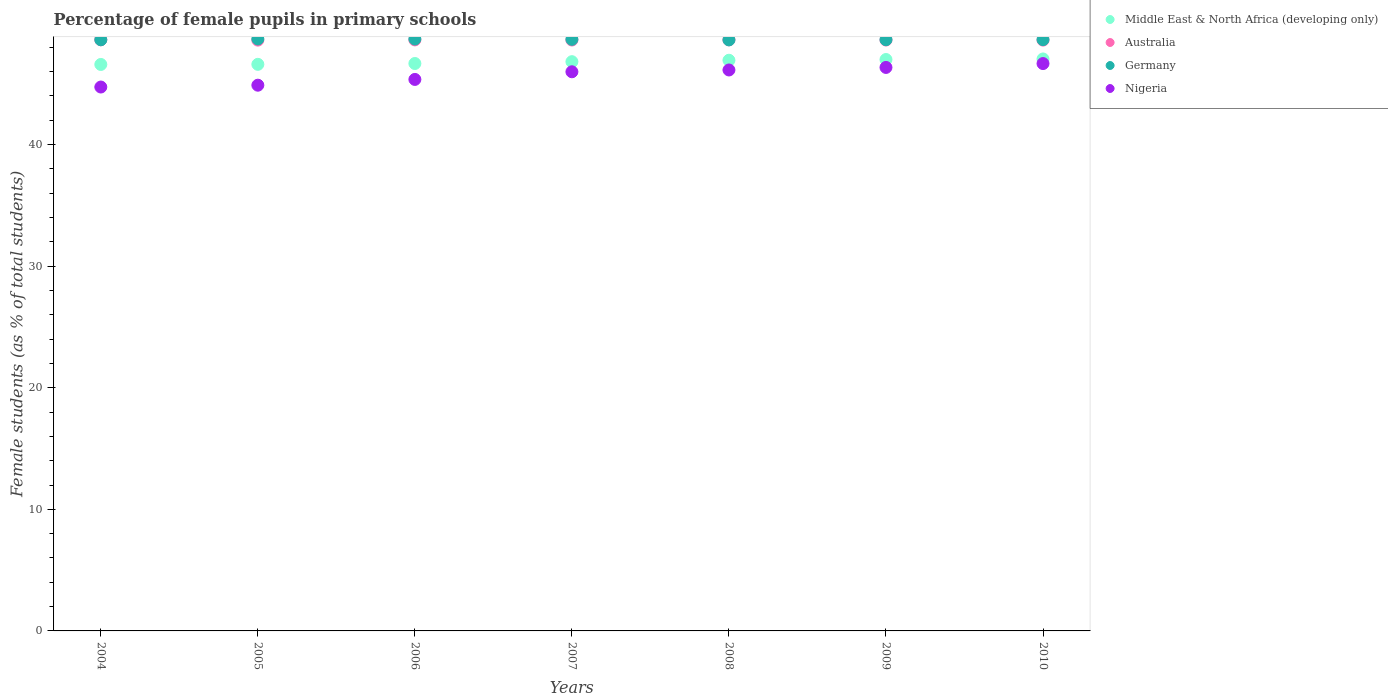What is the percentage of female pupils in primary schools in Australia in 2005?
Give a very brief answer. 48.59. Across all years, what is the maximum percentage of female pupils in primary schools in Nigeria?
Offer a very short reply. 46.66. Across all years, what is the minimum percentage of female pupils in primary schools in Germany?
Give a very brief answer. 48.61. In which year was the percentage of female pupils in primary schools in Australia maximum?
Ensure brevity in your answer.  2004. What is the total percentage of female pupils in primary schools in Nigeria in the graph?
Provide a succinct answer. 320.11. What is the difference between the percentage of female pupils in primary schools in Australia in 2004 and that in 2005?
Offer a very short reply. 0.02. What is the difference between the percentage of female pupils in primary schools in Germany in 2005 and the percentage of female pupils in primary schools in Australia in 2007?
Ensure brevity in your answer.  0.09. What is the average percentage of female pupils in primary schools in Nigeria per year?
Your answer should be compact. 45.73. In the year 2005, what is the difference between the percentage of female pupils in primary schools in Germany and percentage of female pupils in primary schools in Middle East & North Africa (developing only)?
Make the answer very short. 2.09. What is the ratio of the percentage of female pupils in primary schools in Germany in 2005 to that in 2008?
Provide a succinct answer. 1. Is the difference between the percentage of female pupils in primary schools in Germany in 2004 and 2008 greater than the difference between the percentage of female pupils in primary schools in Middle East & North Africa (developing only) in 2004 and 2008?
Offer a terse response. Yes. What is the difference between the highest and the second highest percentage of female pupils in primary schools in Nigeria?
Provide a succinct answer. 0.32. What is the difference between the highest and the lowest percentage of female pupils in primary schools in Nigeria?
Make the answer very short. 1.93. In how many years, is the percentage of female pupils in primary schools in Australia greater than the average percentage of female pupils in primary schools in Australia taken over all years?
Your answer should be very brief. 3. Is the sum of the percentage of female pupils in primary schools in Nigeria in 2005 and 2010 greater than the maximum percentage of female pupils in primary schools in Middle East & North Africa (developing only) across all years?
Ensure brevity in your answer.  Yes. Is it the case that in every year, the sum of the percentage of female pupils in primary schools in Australia and percentage of female pupils in primary schools in Nigeria  is greater than the sum of percentage of female pupils in primary schools in Germany and percentage of female pupils in primary schools in Middle East & North Africa (developing only)?
Give a very brief answer. No. Does the percentage of female pupils in primary schools in Germany monotonically increase over the years?
Offer a very short reply. No. Is the percentage of female pupils in primary schools in Germany strictly greater than the percentage of female pupils in primary schools in Nigeria over the years?
Your answer should be very brief. Yes. How many dotlines are there?
Make the answer very short. 4. How many years are there in the graph?
Your response must be concise. 7. What is the difference between two consecutive major ticks on the Y-axis?
Your answer should be very brief. 10. Does the graph contain any zero values?
Make the answer very short. No. How many legend labels are there?
Provide a succinct answer. 4. What is the title of the graph?
Your answer should be compact. Percentage of female pupils in primary schools. Does "French Polynesia" appear as one of the legend labels in the graph?
Offer a terse response. No. What is the label or title of the Y-axis?
Keep it short and to the point. Female students (as % of total students). What is the Female students (as % of total students) in Middle East & North Africa (developing only) in 2004?
Make the answer very short. 46.59. What is the Female students (as % of total students) in Australia in 2004?
Ensure brevity in your answer.  48.62. What is the Female students (as % of total students) in Germany in 2004?
Ensure brevity in your answer.  48.62. What is the Female students (as % of total students) in Nigeria in 2004?
Offer a very short reply. 44.73. What is the Female students (as % of total students) of Middle East & North Africa (developing only) in 2005?
Provide a succinct answer. 46.6. What is the Female students (as % of total students) of Australia in 2005?
Offer a terse response. 48.59. What is the Female students (as % of total students) of Germany in 2005?
Your answer should be very brief. 48.69. What is the Female students (as % of total students) in Nigeria in 2005?
Offer a terse response. 44.88. What is the Female students (as % of total students) of Middle East & North Africa (developing only) in 2006?
Your response must be concise. 46.67. What is the Female students (as % of total students) in Australia in 2006?
Your answer should be compact. 48.61. What is the Female students (as % of total students) in Germany in 2006?
Offer a terse response. 48.68. What is the Female students (as % of total students) of Nigeria in 2006?
Your answer should be very brief. 45.36. What is the Female students (as % of total students) in Middle East & North Africa (developing only) in 2007?
Make the answer very short. 46.82. What is the Female students (as % of total students) in Australia in 2007?
Your answer should be very brief. 48.6. What is the Female students (as % of total students) in Germany in 2007?
Give a very brief answer. 48.66. What is the Female students (as % of total students) of Nigeria in 2007?
Offer a terse response. 45.99. What is the Female students (as % of total students) in Middle East & North Africa (developing only) in 2008?
Your response must be concise. 46.94. What is the Female students (as % of total students) in Australia in 2008?
Offer a very short reply. 48.62. What is the Female students (as % of total students) in Germany in 2008?
Your answer should be compact. 48.61. What is the Female students (as % of total students) in Nigeria in 2008?
Keep it short and to the point. 46.14. What is the Female students (as % of total students) of Middle East & North Africa (developing only) in 2009?
Your answer should be compact. 47. What is the Female students (as % of total students) of Australia in 2009?
Provide a short and direct response. 48.6. What is the Female students (as % of total students) in Germany in 2009?
Ensure brevity in your answer.  48.63. What is the Female students (as % of total students) of Nigeria in 2009?
Your answer should be very brief. 46.35. What is the Female students (as % of total students) in Middle East & North Africa (developing only) in 2010?
Provide a succinct answer. 47.04. What is the Female students (as % of total students) of Australia in 2010?
Offer a very short reply. 48.59. What is the Female students (as % of total students) in Germany in 2010?
Offer a very short reply. 48.63. What is the Female students (as % of total students) in Nigeria in 2010?
Ensure brevity in your answer.  46.66. Across all years, what is the maximum Female students (as % of total students) of Middle East & North Africa (developing only)?
Offer a terse response. 47.04. Across all years, what is the maximum Female students (as % of total students) of Australia?
Give a very brief answer. 48.62. Across all years, what is the maximum Female students (as % of total students) in Germany?
Give a very brief answer. 48.69. Across all years, what is the maximum Female students (as % of total students) in Nigeria?
Keep it short and to the point. 46.66. Across all years, what is the minimum Female students (as % of total students) in Middle East & North Africa (developing only)?
Offer a terse response. 46.59. Across all years, what is the minimum Female students (as % of total students) in Australia?
Your answer should be compact. 48.59. Across all years, what is the minimum Female students (as % of total students) of Germany?
Provide a short and direct response. 48.61. Across all years, what is the minimum Female students (as % of total students) of Nigeria?
Give a very brief answer. 44.73. What is the total Female students (as % of total students) in Middle East & North Africa (developing only) in the graph?
Provide a short and direct response. 327.65. What is the total Female students (as % of total students) in Australia in the graph?
Give a very brief answer. 340.23. What is the total Female students (as % of total students) of Germany in the graph?
Offer a very short reply. 340.52. What is the total Female students (as % of total students) in Nigeria in the graph?
Provide a succinct answer. 320.11. What is the difference between the Female students (as % of total students) of Middle East & North Africa (developing only) in 2004 and that in 2005?
Provide a succinct answer. -0.01. What is the difference between the Female students (as % of total students) in Australia in 2004 and that in 2005?
Ensure brevity in your answer.  0.02. What is the difference between the Female students (as % of total students) in Germany in 2004 and that in 2005?
Make the answer very short. -0.06. What is the difference between the Female students (as % of total students) in Nigeria in 2004 and that in 2005?
Your answer should be compact. -0.15. What is the difference between the Female students (as % of total students) in Middle East & North Africa (developing only) in 2004 and that in 2006?
Provide a short and direct response. -0.08. What is the difference between the Female students (as % of total students) in Australia in 2004 and that in 2006?
Provide a short and direct response. 0.01. What is the difference between the Female students (as % of total students) in Germany in 2004 and that in 2006?
Make the answer very short. -0.06. What is the difference between the Female students (as % of total students) in Nigeria in 2004 and that in 2006?
Offer a terse response. -0.62. What is the difference between the Female students (as % of total students) of Middle East & North Africa (developing only) in 2004 and that in 2007?
Make the answer very short. -0.23. What is the difference between the Female students (as % of total students) of Australia in 2004 and that in 2007?
Give a very brief answer. 0.02. What is the difference between the Female students (as % of total students) of Germany in 2004 and that in 2007?
Your answer should be compact. -0.04. What is the difference between the Female students (as % of total students) of Nigeria in 2004 and that in 2007?
Offer a very short reply. -1.25. What is the difference between the Female students (as % of total students) of Middle East & North Africa (developing only) in 2004 and that in 2008?
Your answer should be very brief. -0.35. What is the difference between the Female students (as % of total students) of Australia in 2004 and that in 2008?
Your response must be concise. 0. What is the difference between the Female students (as % of total students) in Germany in 2004 and that in 2008?
Your response must be concise. 0.01. What is the difference between the Female students (as % of total students) in Nigeria in 2004 and that in 2008?
Your answer should be very brief. -1.4. What is the difference between the Female students (as % of total students) of Middle East & North Africa (developing only) in 2004 and that in 2009?
Keep it short and to the point. -0.41. What is the difference between the Female students (as % of total students) in Australia in 2004 and that in 2009?
Provide a succinct answer. 0.02. What is the difference between the Female students (as % of total students) of Germany in 2004 and that in 2009?
Your answer should be compact. -0.01. What is the difference between the Female students (as % of total students) of Nigeria in 2004 and that in 2009?
Your answer should be very brief. -1.61. What is the difference between the Female students (as % of total students) of Middle East & North Africa (developing only) in 2004 and that in 2010?
Keep it short and to the point. -0.45. What is the difference between the Female students (as % of total students) in Australia in 2004 and that in 2010?
Your response must be concise. 0.02. What is the difference between the Female students (as % of total students) in Germany in 2004 and that in 2010?
Provide a short and direct response. -0.01. What is the difference between the Female students (as % of total students) of Nigeria in 2004 and that in 2010?
Offer a very short reply. -1.93. What is the difference between the Female students (as % of total students) of Middle East & North Africa (developing only) in 2005 and that in 2006?
Your answer should be compact. -0.07. What is the difference between the Female students (as % of total students) of Australia in 2005 and that in 2006?
Make the answer very short. -0.02. What is the difference between the Female students (as % of total students) of Germany in 2005 and that in 2006?
Your response must be concise. 0.01. What is the difference between the Female students (as % of total students) of Nigeria in 2005 and that in 2006?
Your answer should be very brief. -0.47. What is the difference between the Female students (as % of total students) in Middle East & North Africa (developing only) in 2005 and that in 2007?
Your answer should be very brief. -0.22. What is the difference between the Female students (as % of total students) in Australia in 2005 and that in 2007?
Provide a succinct answer. -0.01. What is the difference between the Female students (as % of total students) of Germany in 2005 and that in 2007?
Your answer should be compact. 0.03. What is the difference between the Female students (as % of total students) in Nigeria in 2005 and that in 2007?
Your answer should be very brief. -1.1. What is the difference between the Female students (as % of total students) in Middle East & North Africa (developing only) in 2005 and that in 2008?
Your response must be concise. -0.34. What is the difference between the Female students (as % of total students) of Australia in 2005 and that in 2008?
Offer a very short reply. -0.02. What is the difference between the Female students (as % of total students) in Germany in 2005 and that in 2008?
Provide a short and direct response. 0.08. What is the difference between the Female students (as % of total students) in Nigeria in 2005 and that in 2008?
Keep it short and to the point. -1.25. What is the difference between the Female students (as % of total students) of Middle East & North Africa (developing only) in 2005 and that in 2009?
Keep it short and to the point. -0.4. What is the difference between the Female students (as % of total students) in Australia in 2005 and that in 2009?
Give a very brief answer. -0.01. What is the difference between the Female students (as % of total students) in Germany in 2005 and that in 2009?
Ensure brevity in your answer.  0.06. What is the difference between the Female students (as % of total students) in Nigeria in 2005 and that in 2009?
Keep it short and to the point. -1.46. What is the difference between the Female students (as % of total students) in Middle East & North Africa (developing only) in 2005 and that in 2010?
Your answer should be very brief. -0.44. What is the difference between the Female students (as % of total students) in Australia in 2005 and that in 2010?
Offer a very short reply. -0. What is the difference between the Female students (as % of total students) in Germany in 2005 and that in 2010?
Offer a very short reply. 0.05. What is the difference between the Female students (as % of total students) of Nigeria in 2005 and that in 2010?
Offer a very short reply. -1.78. What is the difference between the Female students (as % of total students) of Middle East & North Africa (developing only) in 2006 and that in 2007?
Keep it short and to the point. -0.15. What is the difference between the Female students (as % of total students) in Australia in 2006 and that in 2007?
Your response must be concise. 0.01. What is the difference between the Female students (as % of total students) of Germany in 2006 and that in 2007?
Ensure brevity in your answer.  0.02. What is the difference between the Female students (as % of total students) of Nigeria in 2006 and that in 2007?
Your answer should be very brief. -0.63. What is the difference between the Female students (as % of total students) of Middle East & North Africa (developing only) in 2006 and that in 2008?
Your answer should be compact. -0.27. What is the difference between the Female students (as % of total students) in Australia in 2006 and that in 2008?
Provide a succinct answer. -0.01. What is the difference between the Female students (as % of total students) in Germany in 2006 and that in 2008?
Your answer should be very brief. 0.07. What is the difference between the Female students (as % of total students) of Nigeria in 2006 and that in 2008?
Provide a succinct answer. -0.78. What is the difference between the Female students (as % of total students) in Middle East & North Africa (developing only) in 2006 and that in 2009?
Give a very brief answer. -0.33. What is the difference between the Female students (as % of total students) in Germany in 2006 and that in 2009?
Make the answer very short. 0.05. What is the difference between the Female students (as % of total students) in Nigeria in 2006 and that in 2009?
Provide a succinct answer. -0.99. What is the difference between the Female students (as % of total students) in Middle East & North Africa (developing only) in 2006 and that in 2010?
Your response must be concise. -0.37. What is the difference between the Female students (as % of total students) in Australia in 2006 and that in 2010?
Your response must be concise. 0.02. What is the difference between the Female students (as % of total students) in Germany in 2006 and that in 2010?
Offer a terse response. 0.05. What is the difference between the Female students (as % of total students) in Nigeria in 2006 and that in 2010?
Your answer should be very brief. -1.31. What is the difference between the Female students (as % of total students) of Middle East & North Africa (developing only) in 2007 and that in 2008?
Ensure brevity in your answer.  -0.12. What is the difference between the Female students (as % of total students) in Australia in 2007 and that in 2008?
Your response must be concise. -0.02. What is the difference between the Female students (as % of total students) in Germany in 2007 and that in 2008?
Provide a short and direct response. 0.05. What is the difference between the Female students (as % of total students) in Nigeria in 2007 and that in 2008?
Your answer should be very brief. -0.15. What is the difference between the Female students (as % of total students) in Middle East & North Africa (developing only) in 2007 and that in 2009?
Ensure brevity in your answer.  -0.18. What is the difference between the Female students (as % of total students) of Australia in 2007 and that in 2009?
Offer a very short reply. -0. What is the difference between the Female students (as % of total students) of Germany in 2007 and that in 2009?
Your answer should be compact. 0.03. What is the difference between the Female students (as % of total students) in Nigeria in 2007 and that in 2009?
Your answer should be compact. -0.36. What is the difference between the Female students (as % of total students) of Middle East & North Africa (developing only) in 2007 and that in 2010?
Offer a very short reply. -0.22. What is the difference between the Female students (as % of total students) of Australia in 2007 and that in 2010?
Keep it short and to the point. 0.01. What is the difference between the Female students (as % of total students) of Germany in 2007 and that in 2010?
Offer a very short reply. 0.02. What is the difference between the Female students (as % of total students) of Nigeria in 2007 and that in 2010?
Your answer should be compact. -0.68. What is the difference between the Female students (as % of total students) of Middle East & North Africa (developing only) in 2008 and that in 2009?
Offer a terse response. -0.06. What is the difference between the Female students (as % of total students) in Australia in 2008 and that in 2009?
Offer a very short reply. 0.02. What is the difference between the Female students (as % of total students) in Germany in 2008 and that in 2009?
Your answer should be compact. -0.02. What is the difference between the Female students (as % of total students) of Nigeria in 2008 and that in 2009?
Your response must be concise. -0.21. What is the difference between the Female students (as % of total students) in Middle East & North Africa (developing only) in 2008 and that in 2010?
Keep it short and to the point. -0.11. What is the difference between the Female students (as % of total students) of Australia in 2008 and that in 2010?
Make the answer very short. 0.02. What is the difference between the Female students (as % of total students) of Germany in 2008 and that in 2010?
Your response must be concise. -0.02. What is the difference between the Female students (as % of total students) in Nigeria in 2008 and that in 2010?
Offer a very short reply. -0.53. What is the difference between the Female students (as % of total students) of Middle East & North Africa (developing only) in 2009 and that in 2010?
Make the answer very short. -0.05. What is the difference between the Female students (as % of total students) of Australia in 2009 and that in 2010?
Keep it short and to the point. 0.01. What is the difference between the Female students (as % of total students) in Germany in 2009 and that in 2010?
Provide a short and direct response. -0.01. What is the difference between the Female students (as % of total students) in Nigeria in 2009 and that in 2010?
Offer a very short reply. -0.32. What is the difference between the Female students (as % of total students) of Middle East & North Africa (developing only) in 2004 and the Female students (as % of total students) of Australia in 2005?
Your answer should be very brief. -2. What is the difference between the Female students (as % of total students) in Middle East & North Africa (developing only) in 2004 and the Female students (as % of total students) in Germany in 2005?
Provide a short and direct response. -2.1. What is the difference between the Female students (as % of total students) of Middle East & North Africa (developing only) in 2004 and the Female students (as % of total students) of Nigeria in 2005?
Your answer should be very brief. 1.71. What is the difference between the Female students (as % of total students) in Australia in 2004 and the Female students (as % of total students) in Germany in 2005?
Your answer should be very brief. -0.07. What is the difference between the Female students (as % of total students) in Australia in 2004 and the Female students (as % of total students) in Nigeria in 2005?
Make the answer very short. 3.73. What is the difference between the Female students (as % of total students) in Germany in 2004 and the Female students (as % of total students) in Nigeria in 2005?
Offer a very short reply. 3.74. What is the difference between the Female students (as % of total students) in Middle East & North Africa (developing only) in 2004 and the Female students (as % of total students) in Australia in 2006?
Offer a very short reply. -2.02. What is the difference between the Female students (as % of total students) of Middle East & North Africa (developing only) in 2004 and the Female students (as % of total students) of Germany in 2006?
Offer a very short reply. -2.09. What is the difference between the Female students (as % of total students) in Middle East & North Africa (developing only) in 2004 and the Female students (as % of total students) in Nigeria in 2006?
Your response must be concise. 1.23. What is the difference between the Female students (as % of total students) of Australia in 2004 and the Female students (as % of total students) of Germany in 2006?
Ensure brevity in your answer.  -0.06. What is the difference between the Female students (as % of total students) of Australia in 2004 and the Female students (as % of total students) of Nigeria in 2006?
Provide a short and direct response. 3.26. What is the difference between the Female students (as % of total students) in Germany in 2004 and the Female students (as % of total students) in Nigeria in 2006?
Your answer should be very brief. 3.26. What is the difference between the Female students (as % of total students) of Middle East & North Africa (developing only) in 2004 and the Female students (as % of total students) of Australia in 2007?
Your answer should be compact. -2.01. What is the difference between the Female students (as % of total students) of Middle East & North Africa (developing only) in 2004 and the Female students (as % of total students) of Germany in 2007?
Make the answer very short. -2.07. What is the difference between the Female students (as % of total students) of Middle East & North Africa (developing only) in 2004 and the Female students (as % of total students) of Nigeria in 2007?
Provide a succinct answer. 0.6. What is the difference between the Female students (as % of total students) of Australia in 2004 and the Female students (as % of total students) of Germany in 2007?
Offer a terse response. -0.04. What is the difference between the Female students (as % of total students) of Australia in 2004 and the Female students (as % of total students) of Nigeria in 2007?
Your answer should be compact. 2.63. What is the difference between the Female students (as % of total students) of Germany in 2004 and the Female students (as % of total students) of Nigeria in 2007?
Keep it short and to the point. 2.63. What is the difference between the Female students (as % of total students) of Middle East & North Africa (developing only) in 2004 and the Female students (as % of total students) of Australia in 2008?
Provide a succinct answer. -2.03. What is the difference between the Female students (as % of total students) in Middle East & North Africa (developing only) in 2004 and the Female students (as % of total students) in Germany in 2008?
Your answer should be very brief. -2.02. What is the difference between the Female students (as % of total students) of Middle East & North Africa (developing only) in 2004 and the Female students (as % of total students) of Nigeria in 2008?
Ensure brevity in your answer.  0.45. What is the difference between the Female students (as % of total students) of Australia in 2004 and the Female students (as % of total students) of Germany in 2008?
Your answer should be compact. 0.01. What is the difference between the Female students (as % of total students) in Australia in 2004 and the Female students (as % of total students) in Nigeria in 2008?
Your answer should be compact. 2.48. What is the difference between the Female students (as % of total students) in Germany in 2004 and the Female students (as % of total students) in Nigeria in 2008?
Offer a terse response. 2.49. What is the difference between the Female students (as % of total students) in Middle East & North Africa (developing only) in 2004 and the Female students (as % of total students) in Australia in 2009?
Offer a very short reply. -2.01. What is the difference between the Female students (as % of total students) of Middle East & North Africa (developing only) in 2004 and the Female students (as % of total students) of Germany in 2009?
Your response must be concise. -2.04. What is the difference between the Female students (as % of total students) in Middle East & North Africa (developing only) in 2004 and the Female students (as % of total students) in Nigeria in 2009?
Provide a succinct answer. 0.24. What is the difference between the Female students (as % of total students) of Australia in 2004 and the Female students (as % of total students) of Germany in 2009?
Provide a short and direct response. -0.01. What is the difference between the Female students (as % of total students) of Australia in 2004 and the Female students (as % of total students) of Nigeria in 2009?
Make the answer very short. 2.27. What is the difference between the Female students (as % of total students) in Germany in 2004 and the Female students (as % of total students) in Nigeria in 2009?
Your response must be concise. 2.28. What is the difference between the Female students (as % of total students) in Middle East & North Africa (developing only) in 2004 and the Female students (as % of total students) in Australia in 2010?
Offer a terse response. -2. What is the difference between the Female students (as % of total students) in Middle East & North Africa (developing only) in 2004 and the Female students (as % of total students) in Germany in 2010?
Ensure brevity in your answer.  -2.04. What is the difference between the Female students (as % of total students) of Middle East & North Africa (developing only) in 2004 and the Female students (as % of total students) of Nigeria in 2010?
Give a very brief answer. -0.07. What is the difference between the Female students (as % of total students) in Australia in 2004 and the Female students (as % of total students) in Germany in 2010?
Offer a very short reply. -0.02. What is the difference between the Female students (as % of total students) in Australia in 2004 and the Female students (as % of total students) in Nigeria in 2010?
Keep it short and to the point. 1.95. What is the difference between the Female students (as % of total students) of Germany in 2004 and the Female students (as % of total students) of Nigeria in 2010?
Offer a very short reply. 1.96. What is the difference between the Female students (as % of total students) of Middle East & North Africa (developing only) in 2005 and the Female students (as % of total students) of Australia in 2006?
Offer a terse response. -2.01. What is the difference between the Female students (as % of total students) of Middle East & North Africa (developing only) in 2005 and the Female students (as % of total students) of Germany in 2006?
Offer a very short reply. -2.08. What is the difference between the Female students (as % of total students) of Middle East & North Africa (developing only) in 2005 and the Female students (as % of total students) of Nigeria in 2006?
Make the answer very short. 1.24. What is the difference between the Female students (as % of total students) in Australia in 2005 and the Female students (as % of total students) in Germany in 2006?
Your answer should be very brief. -0.09. What is the difference between the Female students (as % of total students) of Australia in 2005 and the Female students (as % of total students) of Nigeria in 2006?
Your response must be concise. 3.23. What is the difference between the Female students (as % of total students) of Germany in 2005 and the Female students (as % of total students) of Nigeria in 2006?
Your response must be concise. 3.33. What is the difference between the Female students (as % of total students) of Middle East & North Africa (developing only) in 2005 and the Female students (as % of total students) of Australia in 2007?
Your answer should be compact. -2. What is the difference between the Female students (as % of total students) of Middle East & North Africa (developing only) in 2005 and the Female students (as % of total students) of Germany in 2007?
Provide a succinct answer. -2.06. What is the difference between the Female students (as % of total students) of Middle East & North Africa (developing only) in 2005 and the Female students (as % of total students) of Nigeria in 2007?
Provide a short and direct response. 0.61. What is the difference between the Female students (as % of total students) in Australia in 2005 and the Female students (as % of total students) in Germany in 2007?
Keep it short and to the point. -0.06. What is the difference between the Female students (as % of total students) of Australia in 2005 and the Female students (as % of total students) of Nigeria in 2007?
Your response must be concise. 2.6. What is the difference between the Female students (as % of total students) in Germany in 2005 and the Female students (as % of total students) in Nigeria in 2007?
Provide a succinct answer. 2.7. What is the difference between the Female students (as % of total students) of Middle East & North Africa (developing only) in 2005 and the Female students (as % of total students) of Australia in 2008?
Offer a very short reply. -2.02. What is the difference between the Female students (as % of total students) in Middle East & North Africa (developing only) in 2005 and the Female students (as % of total students) in Germany in 2008?
Offer a very short reply. -2.01. What is the difference between the Female students (as % of total students) of Middle East & North Africa (developing only) in 2005 and the Female students (as % of total students) of Nigeria in 2008?
Your response must be concise. 0.46. What is the difference between the Female students (as % of total students) of Australia in 2005 and the Female students (as % of total students) of Germany in 2008?
Your response must be concise. -0.02. What is the difference between the Female students (as % of total students) in Australia in 2005 and the Female students (as % of total students) in Nigeria in 2008?
Keep it short and to the point. 2.46. What is the difference between the Female students (as % of total students) in Germany in 2005 and the Female students (as % of total students) in Nigeria in 2008?
Offer a very short reply. 2.55. What is the difference between the Female students (as % of total students) in Middle East & North Africa (developing only) in 2005 and the Female students (as % of total students) in Australia in 2009?
Your response must be concise. -2. What is the difference between the Female students (as % of total students) in Middle East & North Africa (developing only) in 2005 and the Female students (as % of total students) in Germany in 2009?
Your answer should be compact. -2.03. What is the difference between the Female students (as % of total students) of Middle East & North Africa (developing only) in 2005 and the Female students (as % of total students) of Nigeria in 2009?
Keep it short and to the point. 0.25. What is the difference between the Female students (as % of total students) of Australia in 2005 and the Female students (as % of total students) of Germany in 2009?
Offer a very short reply. -0.03. What is the difference between the Female students (as % of total students) in Australia in 2005 and the Female students (as % of total students) in Nigeria in 2009?
Your answer should be compact. 2.25. What is the difference between the Female students (as % of total students) in Germany in 2005 and the Female students (as % of total students) in Nigeria in 2009?
Your answer should be very brief. 2.34. What is the difference between the Female students (as % of total students) in Middle East & North Africa (developing only) in 2005 and the Female students (as % of total students) in Australia in 2010?
Your answer should be very brief. -1.99. What is the difference between the Female students (as % of total students) in Middle East & North Africa (developing only) in 2005 and the Female students (as % of total students) in Germany in 2010?
Your response must be concise. -2.03. What is the difference between the Female students (as % of total students) of Middle East & North Africa (developing only) in 2005 and the Female students (as % of total students) of Nigeria in 2010?
Ensure brevity in your answer.  -0.06. What is the difference between the Female students (as % of total students) of Australia in 2005 and the Female students (as % of total students) of Germany in 2010?
Your response must be concise. -0.04. What is the difference between the Female students (as % of total students) in Australia in 2005 and the Female students (as % of total students) in Nigeria in 2010?
Your answer should be compact. 1.93. What is the difference between the Female students (as % of total students) in Germany in 2005 and the Female students (as % of total students) in Nigeria in 2010?
Provide a succinct answer. 2.02. What is the difference between the Female students (as % of total students) of Middle East & North Africa (developing only) in 2006 and the Female students (as % of total students) of Australia in 2007?
Offer a very short reply. -1.93. What is the difference between the Female students (as % of total students) in Middle East & North Africa (developing only) in 2006 and the Female students (as % of total students) in Germany in 2007?
Ensure brevity in your answer.  -1.99. What is the difference between the Female students (as % of total students) in Middle East & North Africa (developing only) in 2006 and the Female students (as % of total students) in Nigeria in 2007?
Provide a succinct answer. 0.68. What is the difference between the Female students (as % of total students) of Australia in 2006 and the Female students (as % of total students) of Germany in 2007?
Ensure brevity in your answer.  -0.05. What is the difference between the Female students (as % of total students) in Australia in 2006 and the Female students (as % of total students) in Nigeria in 2007?
Keep it short and to the point. 2.62. What is the difference between the Female students (as % of total students) in Germany in 2006 and the Female students (as % of total students) in Nigeria in 2007?
Provide a succinct answer. 2.69. What is the difference between the Female students (as % of total students) of Middle East & North Africa (developing only) in 2006 and the Female students (as % of total students) of Australia in 2008?
Your answer should be very brief. -1.95. What is the difference between the Female students (as % of total students) in Middle East & North Africa (developing only) in 2006 and the Female students (as % of total students) in Germany in 2008?
Make the answer very short. -1.94. What is the difference between the Female students (as % of total students) in Middle East & North Africa (developing only) in 2006 and the Female students (as % of total students) in Nigeria in 2008?
Ensure brevity in your answer.  0.53. What is the difference between the Female students (as % of total students) of Australia in 2006 and the Female students (as % of total students) of Germany in 2008?
Give a very brief answer. -0. What is the difference between the Female students (as % of total students) of Australia in 2006 and the Female students (as % of total students) of Nigeria in 2008?
Your response must be concise. 2.47. What is the difference between the Female students (as % of total students) of Germany in 2006 and the Female students (as % of total students) of Nigeria in 2008?
Offer a terse response. 2.54. What is the difference between the Female students (as % of total students) of Middle East & North Africa (developing only) in 2006 and the Female students (as % of total students) of Australia in 2009?
Make the answer very short. -1.93. What is the difference between the Female students (as % of total students) of Middle East & North Africa (developing only) in 2006 and the Female students (as % of total students) of Germany in 2009?
Provide a short and direct response. -1.96. What is the difference between the Female students (as % of total students) in Middle East & North Africa (developing only) in 2006 and the Female students (as % of total students) in Nigeria in 2009?
Ensure brevity in your answer.  0.32. What is the difference between the Female students (as % of total students) of Australia in 2006 and the Female students (as % of total students) of Germany in 2009?
Offer a very short reply. -0.02. What is the difference between the Female students (as % of total students) in Australia in 2006 and the Female students (as % of total students) in Nigeria in 2009?
Your answer should be very brief. 2.26. What is the difference between the Female students (as % of total students) in Germany in 2006 and the Female students (as % of total students) in Nigeria in 2009?
Keep it short and to the point. 2.33. What is the difference between the Female students (as % of total students) of Middle East & North Africa (developing only) in 2006 and the Female students (as % of total students) of Australia in 2010?
Your response must be concise. -1.92. What is the difference between the Female students (as % of total students) of Middle East & North Africa (developing only) in 2006 and the Female students (as % of total students) of Germany in 2010?
Your response must be concise. -1.97. What is the difference between the Female students (as % of total students) in Middle East & North Africa (developing only) in 2006 and the Female students (as % of total students) in Nigeria in 2010?
Your response must be concise. 0. What is the difference between the Female students (as % of total students) of Australia in 2006 and the Female students (as % of total students) of Germany in 2010?
Your answer should be compact. -0.02. What is the difference between the Female students (as % of total students) of Australia in 2006 and the Female students (as % of total students) of Nigeria in 2010?
Offer a terse response. 1.95. What is the difference between the Female students (as % of total students) in Germany in 2006 and the Female students (as % of total students) in Nigeria in 2010?
Your answer should be compact. 2.02. What is the difference between the Female students (as % of total students) in Middle East & North Africa (developing only) in 2007 and the Female students (as % of total students) in Australia in 2008?
Your answer should be compact. -1.8. What is the difference between the Female students (as % of total students) in Middle East & North Africa (developing only) in 2007 and the Female students (as % of total students) in Germany in 2008?
Offer a terse response. -1.79. What is the difference between the Female students (as % of total students) in Middle East & North Africa (developing only) in 2007 and the Female students (as % of total students) in Nigeria in 2008?
Offer a terse response. 0.68. What is the difference between the Female students (as % of total students) of Australia in 2007 and the Female students (as % of total students) of Germany in 2008?
Offer a terse response. -0.01. What is the difference between the Female students (as % of total students) of Australia in 2007 and the Female students (as % of total students) of Nigeria in 2008?
Make the answer very short. 2.46. What is the difference between the Female students (as % of total students) of Germany in 2007 and the Female students (as % of total students) of Nigeria in 2008?
Keep it short and to the point. 2.52. What is the difference between the Female students (as % of total students) in Middle East & North Africa (developing only) in 2007 and the Female students (as % of total students) in Australia in 2009?
Give a very brief answer. -1.78. What is the difference between the Female students (as % of total students) of Middle East & North Africa (developing only) in 2007 and the Female students (as % of total students) of Germany in 2009?
Give a very brief answer. -1.81. What is the difference between the Female students (as % of total students) of Middle East & North Africa (developing only) in 2007 and the Female students (as % of total students) of Nigeria in 2009?
Your answer should be compact. 0.47. What is the difference between the Female students (as % of total students) of Australia in 2007 and the Female students (as % of total students) of Germany in 2009?
Provide a succinct answer. -0.03. What is the difference between the Female students (as % of total students) of Australia in 2007 and the Female students (as % of total students) of Nigeria in 2009?
Your response must be concise. 2.25. What is the difference between the Female students (as % of total students) of Germany in 2007 and the Female students (as % of total students) of Nigeria in 2009?
Ensure brevity in your answer.  2.31. What is the difference between the Female students (as % of total students) in Middle East & North Africa (developing only) in 2007 and the Female students (as % of total students) in Australia in 2010?
Your answer should be compact. -1.77. What is the difference between the Female students (as % of total students) in Middle East & North Africa (developing only) in 2007 and the Female students (as % of total students) in Germany in 2010?
Make the answer very short. -1.82. What is the difference between the Female students (as % of total students) of Middle East & North Africa (developing only) in 2007 and the Female students (as % of total students) of Nigeria in 2010?
Your response must be concise. 0.15. What is the difference between the Female students (as % of total students) in Australia in 2007 and the Female students (as % of total students) in Germany in 2010?
Give a very brief answer. -0.03. What is the difference between the Female students (as % of total students) in Australia in 2007 and the Female students (as % of total students) in Nigeria in 2010?
Your response must be concise. 1.94. What is the difference between the Female students (as % of total students) in Germany in 2007 and the Female students (as % of total students) in Nigeria in 2010?
Provide a short and direct response. 1.99. What is the difference between the Female students (as % of total students) of Middle East & North Africa (developing only) in 2008 and the Female students (as % of total students) of Australia in 2009?
Offer a very short reply. -1.66. What is the difference between the Female students (as % of total students) in Middle East & North Africa (developing only) in 2008 and the Female students (as % of total students) in Germany in 2009?
Your answer should be very brief. -1.69. What is the difference between the Female students (as % of total students) in Middle East & North Africa (developing only) in 2008 and the Female students (as % of total students) in Nigeria in 2009?
Provide a short and direct response. 0.59. What is the difference between the Female students (as % of total students) of Australia in 2008 and the Female students (as % of total students) of Germany in 2009?
Make the answer very short. -0.01. What is the difference between the Female students (as % of total students) in Australia in 2008 and the Female students (as % of total students) in Nigeria in 2009?
Your answer should be very brief. 2.27. What is the difference between the Female students (as % of total students) of Germany in 2008 and the Female students (as % of total students) of Nigeria in 2009?
Ensure brevity in your answer.  2.26. What is the difference between the Female students (as % of total students) in Middle East & North Africa (developing only) in 2008 and the Female students (as % of total students) in Australia in 2010?
Make the answer very short. -1.66. What is the difference between the Female students (as % of total students) in Middle East & North Africa (developing only) in 2008 and the Female students (as % of total students) in Germany in 2010?
Your answer should be very brief. -1.7. What is the difference between the Female students (as % of total students) of Middle East & North Africa (developing only) in 2008 and the Female students (as % of total students) of Nigeria in 2010?
Ensure brevity in your answer.  0.27. What is the difference between the Female students (as % of total students) of Australia in 2008 and the Female students (as % of total students) of Germany in 2010?
Your answer should be very brief. -0.02. What is the difference between the Female students (as % of total students) of Australia in 2008 and the Female students (as % of total students) of Nigeria in 2010?
Your answer should be compact. 1.95. What is the difference between the Female students (as % of total students) of Germany in 2008 and the Female students (as % of total students) of Nigeria in 2010?
Offer a terse response. 1.95. What is the difference between the Female students (as % of total students) of Middle East & North Africa (developing only) in 2009 and the Female students (as % of total students) of Australia in 2010?
Your answer should be compact. -1.6. What is the difference between the Female students (as % of total students) of Middle East & North Africa (developing only) in 2009 and the Female students (as % of total students) of Germany in 2010?
Provide a short and direct response. -1.64. What is the difference between the Female students (as % of total students) of Middle East & North Africa (developing only) in 2009 and the Female students (as % of total students) of Nigeria in 2010?
Give a very brief answer. 0.33. What is the difference between the Female students (as % of total students) in Australia in 2009 and the Female students (as % of total students) in Germany in 2010?
Your answer should be compact. -0.03. What is the difference between the Female students (as % of total students) of Australia in 2009 and the Female students (as % of total students) of Nigeria in 2010?
Give a very brief answer. 1.94. What is the difference between the Female students (as % of total students) of Germany in 2009 and the Female students (as % of total students) of Nigeria in 2010?
Ensure brevity in your answer.  1.96. What is the average Female students (as % of total students) in Middle East & North Africa (developing only) per year?
Your response must be concise. 46.81. What is the average Female students (as % of total students) of Australia per year?
Offer a terse response. 48.6. What is the average Female students (as % of total students) of Germany per year?
Keep it short and to the point. 48.65. What is the average Female students (as % of total students) in Nigeria per year?
Offer a terse response. 45.73. In the year 2004, what is the difference between the Female students (as % of total students) in Middle East & North Africa (developing only) and Female students (as % of total students) in Australia?
Provide a short and direct response. -2.03. In the year 2004, what is the difference between the Female students (as % of total students) in Middle East & North Africa (developing only) and Female students (as % of total students) in Germany?
Keep it short and to the point. -2.03. In the year 2004, what is the difference between the Female students (as % of total students) in Middle East & North Africa (developing only) and Female students (as % of total students) in Nigeria?
Ensure brevity in your answer.  1.86. In the year 2004, what is the difference between the Female students (as % of total students) in Australia and Female students (as % of total students) in Germany?
Make the answer very short. -0. In the year 2004, what is the difference between the Female students (as % of total students) of Australia and Female students (as % of total students) of Nigeria?
Make the answer very short. 3.88. In the year 2004, what is the difference between the Female students (as % of total students) of Germany and Female students (as % of total students) of Nigeria?
Offer a very short reply. 3.89. In the year 2005, what is the difference between the Female students (as % of total students) of Middle East & North Africa (developing only) and Female students (as % of total students) of Australia?
Offer a very short reply. -1.99. In the year 2005, what is the difference between the Female students (as % of total students) of Middle East & North Africa (developing only) and Female students (as % of total students) of Germany?
Your answer should be very brief. -2.09. In the year 2005, what is the difference between the Female students (as % of total students) of Middle East & North Africa (developing only) and Female students (as % of total students) of Nigeria?
Your answer should be compact. 1.72. In the year 2005, what is the difference between the Female students (as % of total students) in Australia and Female students (as % of total students) in Germany?
Provide a succinct answer. -0.09. In the year 2005, what is the difference between the Female students (as % of total students) in Australia and Female students (as % of total students) in Nigeria?
Your answer should be compact. 3.71. In the year 2005, what is the difference between the Female students (as % of total students) of Germany and Female students (as % of total students) of Nigeria?
Offer a very short reply. 3.8. In the year 2006, what is the difference between the Female students (as % of total students) in Middle East & North Africa (developing only) and Female students (as % of total students) in Australia?
Your answer should be compact. -1.94. In the year 2006, what is the difference between the Female students (as % of total students) of Middle East & North Africa (developing only) and Female students (as % of total students) of Germany?
Give a very brief answer. -2.01. In the year 2006, what is the difference between the Female students (as % of total students) of Middle East & North Africa (developing only) and Female students (as % of total students) of Nigeria?
Ensure brevity in your answer.  1.31. In the year 2006, what is the difference between the Female students (as % of total students) in Australia and Female students (as % of total students) in Germany?
Ensure brevity in your answer.  -0.07. In the year 2006, what is the difference between the Female students (as % of total students) of Australia and Female students (as % of total students) of Nigeria?
Give a very brief answer. 3.25. In the year 2006, what is the difference between the Female students (as % of total students) in Germany and Female students (as % of total students) in Nigeria?
Ensure brevity in your answer.  3.32. In the year 2007, what is the difference between the Female students (as % of total students) in Middle East & North Africa (developing only) and Female students (as % of total students) in Australia?
Give a very brief answer. -1.78. In the year 2007, what is the difference between the Female students (as % of total students) of Middle East & North Africa (developing only) and Female students (as % of total students) of Germany?
Provide a short and direct response. -1.84. In the year 2007, what is the difference between the Female students (as % of total students) of Middle East & North Africa (developing only) and Female students (as % of total students) of Nigeria?
Your answer should be very brief. 0.83. In the year 2007, what is the difference between the Female students (as % of total students) in Australia and Female students (as % of total students) in Germany?
Offer a very short reply. -0.06. In the year 2007, what is the difference between the Female students (as % of total students) in Australia and Female students (as % of total students) in Nigeria?
Your response must be concise. 2.61. In the year 2007, what is the difference between the Female students (as % of total students) of Germany and Female students (as % of total students) of Nigeria?
Ensure brevity in your answer.  2.67. In the year 2008, what is the difference between the Female students (as % of total students) in Middle East & North Africa (developing only) and Female students (as % of total students) in Australia?
Offer a terse response. -1.68. In the year 2008, what is the difference between the Female students (as % of total students) of Middle East & North Africa (developing only) and Female students (as % of total students) of Germany?
Provide a succinct answer. -1.67. In the year 2008, what is the difference between the Female students (as % of total students) in Middle East & North Africa (developing only) and Female students (as % of total students) in Nigeria?
Your answer should be compact. 0.8. In the year 2008, what is the difference between the Female students (as % of total students) of Australia and Female students (as % of total students) of Germany?
Offer a terse response. 0.01. In the year 2008, what is the difference between the Female students (as % of total students) of Australia and Female students (as % of total students) of Nigeria?
Make the answer very short. 2.48. In the year 2008, what is the difference between the Female students (as % of total students) of Germany and Female students (as % of total students) of Nigeria?
Provide a short and direct response. 2.47. In the year 2009, what is the difference between the Female students (as % of total students) of Middle East & North Africa (developing only) and Female students (as % of total students) of Australia?
Provide a short and direct response. -1.6. In the year 2009, what is the difference between the Female students (as % of total students) in Middle East & North Africa (developing only) and Female students (as % of total students) in Germany?
Ensure brevity in your answer.  -1.63. In the year 2009, what is the difference between the Female students (as % of total students) in Middle East & North Africa (developing only) and Female students (as % of total students) in Nigeria?
Ensure brevity in your answer.  0.65. In the year 2009, what is the difference between the Female students (as % of total students) in Australia and Female students (as % of total students) in Germany?
Make the answer very short. -0.03. In the year 2009, what is the difference between the Female students (as % of total students) in Australia and Female students (as % of total students) in Nigeria?
Provide a short and direct response. 2.25. In the year 2009, what is the difference between the Female students (as % of total students) of Germany and Female students (as % of total students) of Nigeria?
Provide a short and direct response. 2.28. In the year 2010, what is the difference between the Female students (as % of total students) of Middle East & North Africa (developing only) and Female students (as % of total students) of Australia?
Provide a short and direct response. -1.55. In the year 2010, what is the difference between the Female students (as % of total students) in Middle East & North Africa (developing only) and Female students (as % of total students) in Germany?
Provide a short and direct response. -1.59. In the year 2010, what is the difference between the Female students (as % of total students) of Middle East & North Africa (developing only) and Female students (as % of total students) of Nigeria?
Provide a succinct answer. 0.38. In the year 2010, what is the difference between the Female students (as % of total students) of Australia and Female students (as % of total students) of Germany?
Your answer should be very brief. -0.04. In the year 2010, what is the difference between the Female students (as % of total students) in Australia and Female students (as % of total students) in Nigeria?
Keep it short and to the point. 1.93. In the year 2010, what is the difference between the Female students (as % of total students) in Germany and Female students (as % of total students) in Nigeria?
Make the answer very short. 1.97. What is the ratio of the Female students (as % of total students) of Middle East & North Africa (developing only) in 2004 to that in 2005?
Your answer should be compact. 1. What is the ratio of the Female students (as % of total students) in Australia in 2004 to that in 2005?
Your response must be concise. 1. What is the ratio of the Female students (as % of total students) of Germany in 2004 to that in 2005?
Offer a terse response. 1. What is the ratio of the Female students (as % of total students) of Nigeria in 2004 to that in 2005?
Ensure brevity in your answer.  1. What is the ratio of the Female students (as % of total students) of Middle East & North Africa (developing only) in 2004 to that in 2006?
Offer a very short reply. 1. What is the ratio of the Female students (as % of total students) of Germany in 2004 to that in 2006?
Your response must be concise. 1. What is the ratio of the Female students (as % of total students) in Nigeria in 2004 to that in 2006?
Give a very brief answer. 0.99. What is the ratio of the Female students (as % of total students) of Middle East & North Africa (developing only) in 2004 to that in 2007?
Provide a short and direct response. 1. What is the ratio of the Female students (as % of total students) of Germany in 2004 to that in 2007?
Offer a very short reply. 1. What is the ratio of the Female students (as % of total students) of Nigeria in 2004 to that in 2007?
Your answer should be very brief. 0.97. What is the ratio of the Female students (as % of total students) of Middle East & North Africa (developing only) in 2004 to that in 2008?
Keep it short and to the point. 0.99. What is the ratio of the Female students (as % of total students) of Australia in 2004 to that in 2008?
Offer a terse response. 1. What is the ratio of the Female students (as % of total students) of Nigeria in 2004 to that in 2008?
Make the answer very short. 0.97. What is the ratio of the Female students (as % of total students) in Middle East & North Africa (developing only) in 2004 to that in 2009?
Your response must be concise. 0.99. What is the ratio of the Female students (as % of total students) in Australia in 2004 to that in 2009?
Your response must be concise. 1. What is the ratio of the Female students (as % of total students) in Germany in 2004 to that in 2009?
Keep it short and to the point. 1. What is the ratio of the Female students (as % of total students) of Nigeria in 2004 to that in 2009?
Keep it short and to the point. 0.97. What is the ratio of the Female students (as % of total students) of Middle East & North Africa (developing only) in 2004 to that in 2010?
Your answer should be very brief. 0.99. What is the ratio of the Female students (as % of total students) of Australia in 2004 to that in 2010?
Offer a very short reply. 1. What is the ratio of the Female students (as % of total students) in Nigeria in 2004 to that in 2010?
Keep it short and to the point. 0.96. What is the ratio of the Female students (as % of total students) in Middle East & North Africa (developing only) in 2005 to that in 2006?
Give a very brief answer. 1. What is the ratio of the Female students (as % of total students) in Australia in 2005 to that in 2006?
Provide a short and direct response. 1. What is the ratio of the Female students (as % of total students) of Australia in 2005 to that in 2007?
Provide a succinct answer. 1. What is the ratio of the Female students (as % of total students) in Germany in 2005 to that in 2007?
Keep it short and to the point. 1. What is the ratio of the Female students (as % of total students) in Nigeria in 2005 to that in 2007?
Give a very brief answer. 0.98. What is the ratio of the Female students (as % of total students) in Nigeria in 2005 to that in 2008?
Provide a succinct answer. 0.97. What is the ratio of the Female students (as % of total students) of Nigeria in 2005 to that in 2009?
Make the answer very short. 0.97. What is the ratio of the Female students (as % of total students) of Middle East & North Africa (developing only) in 2005 to that in 2010?
Offer a terse response. 0.99. What is the ratio of the Female students (as % of total students) in Australia in 2005 to that in 2010?
Make the answer very short. 1. What is the ratio of the Female students (as % of total students) of Germany in 2005 to that in 2010?
Provide a succinct answer. 1. What is the ratio of the Female students (as % of total students) in Nigeria in 2005 to that in 2010?
Your response must be concise. 0.96. What is the ratio of the Female students (as % of total students) of Middle East & North Africa (developing only) in 2006 to that in 2007?
Ensure brevity in your answer.  1. What is the ratio of the Female students (as % of total students) in Germany in 2006 to that in 2007?
Give a very brief answer. 1. What is the ratio of the Female students (as % of total students) of Nigeria in 2006 to that in 2007?
Provide a succinct answer. 0.99. What is the ratio of the Female students (as % of total students) in Australia in 2006 to that in 2008?
Offer a very short reply. 1. What is the ratio of the Female students (as % of total students) in Germany in 2006 to that in 2008?
Your answer should be very brief. 1. What is the ratio of the Female students (as % of total students) of Nigeria in 2006 to that in 2008?
Provide a short and direct response. 0.98. What is the ratio of the Female students (as % of total students) in Middle East & North Africa (developing only) in 2006 to that in 2009?
Offer a very short reply. 0.99. What is the ratio of the Female students (as % of total students) in Australia in 2006 to that in 2009?
Keep it short and to the point. 1. What is the ratio of the Female students (as % of total students) in Nigeria in 2006 to that in 2009?
Provide a succinct answer. 0.98. What is the ratio of the Female students (as % of total students) in Middle East & North Africa (developing only) in 2006 to that in 2010?
Ensure brevity in your answer.  0.99. What is the ratio of the Female students (as % of total students) of Australia in 2006 to that in 2010?
Your answer should be compact. 1. What is the ratio of the Female students (as % of total students) in Nigeria in 2006 to that in 2010?
Your answer should be compact. 0.97. What is the ratio of the Female students (as % of total students) of Middle East & North Africa (developing only) in 2007 to that in 2008?
Ensure brevity in your answer.  1. What is the ratio of the Female students (as % of total students) in Australia in 2007 to that in 2008?
Provide a short and direct response. 1. What is the ratio of the Female students (as % of total students) in Germany in 2007 to that in 2008?
Keep it short and to the point. 1. What is the ratio of the Female students (as % of total students) in Germany in 2007 to that in 2009?
Give a very brief answer. 1. What is the ratio of the Female students (as % of total students) of Middle East & North Africa (developing only) in 2007 to that in 2010?
Your answer should be compact. 1. What is the ratio of the Female students (as % of total students) of Australia in 2007 to that in 2010?
Offer a terse response. 1. What is the ratio of the Female students (as % of total students) of Germany in 2007 to that in 2010?
Give a very brief answer. 1. What is the ratio of the Female students (as % of total students) of Nigeria in 2007 to that in 2010?
Make the answer very short. 0.99. What is the ratio of the Female students (as % of total students) in Australia in 2008 to that in 2009?
Your answer should be very brief. 1. What is the ratio of the Female students (as % of total students) in Nigeria in 2008 to that in 2010?
Give a very brief answer. 0.99. What is the ratio of the Female students (as % of total students) of Germany in 2009 to that in 2010?
Your response must be concise. 1. What is the ratio of the Female students (as % of total students) of Nigeria in 2009 to that in 2010?
Offer a very short reply. 0.99. What is the difference between the highest and the second highest Female students (as % of total students) of Middle East & North Africa (developing only)?
Your answer should be very brief. 0.05. What is the difference between the highest and the second highest Female students (as % of total students) of Australia?
Offer a very short reply. 0. What is the difference between the highest and the second highest Female students (as % of total students) in Germany?
Offer a very short reply. 0.01. What is the difference between the highest and the second highest Female students (as % of total students) of Nigeria?
Your answer should be compact. 0.32. What is the difference between the highest and the lowest Female students (as % of total students) in Middle East & North Africa (developing only)?
Your response must be concise. 0.45. What is the difference between the highest and the lowest Female students (as % of total students) of Australia?
Provide a short and direct response. 0.02. What is the difference between the highest and the lowest Female students (as % of total students) of Germany?
Your response must be concise. 0.08. What is the difference between the highest and the lowest Female students (as % of total students) in Nigeria?
Ensure brevity in your answer.  1.93. 